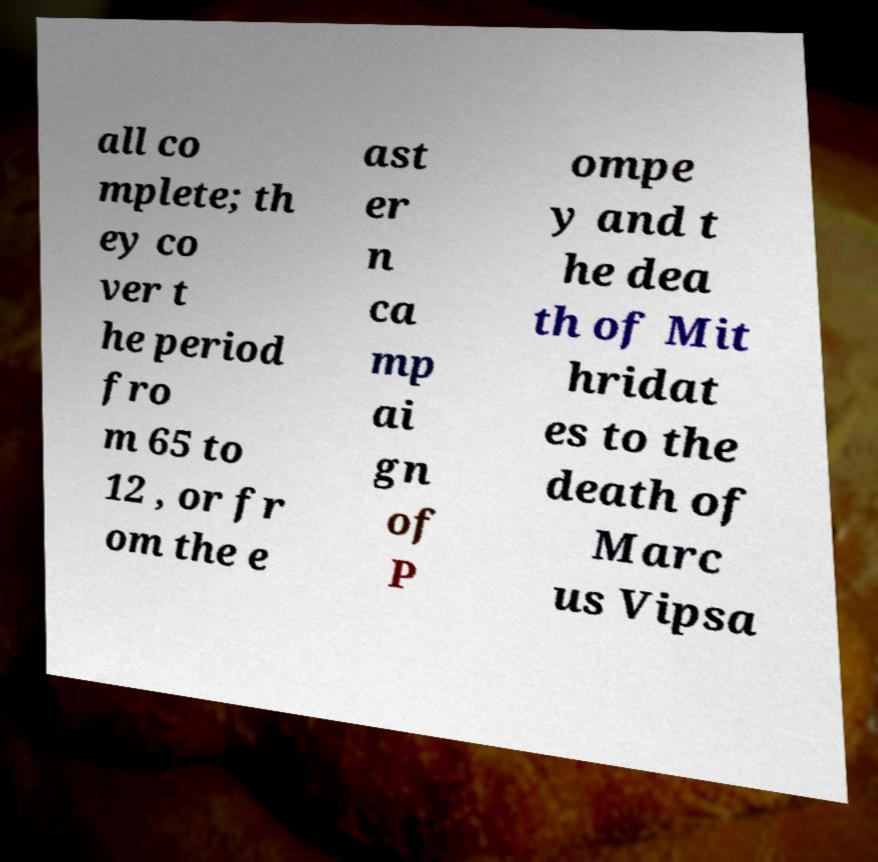Can you accurately transcribe the text from the provided image for me? all co mplete; th ey co ver t he period fro m 65 to 12 , or fr om the e ast er n ca mp ai gn of P ompe y and t he dea th of Mit hridat es to the death of Marc us Vipsa 